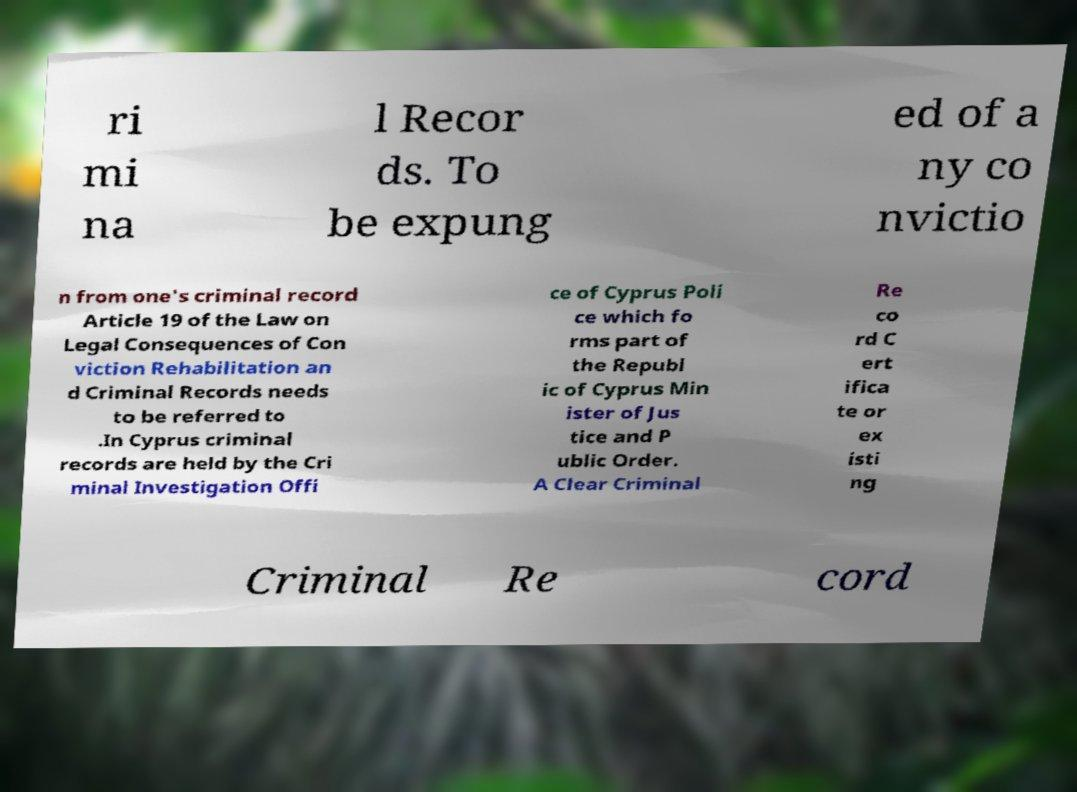There's text embedded in this image that I need extracted. Can you transcribe it verbatim? ri mi na l Recor ds. To be expung ed of a ny co nvictio n from one's criminal record Article 19 of the Law on Legal Consequences of Con viction Rehabilitation an d Criminal Records needs to be referred to .In Cyprus criminal records are held by the Cri minal Investigation Offi ce of Cyprus Poli ce which fo rms part of the Republ ic of Cyprus Min ister of Jus tice and P ublic Order. A Clear Criminal Re co rd C ert ifica te or ex isti ng Criminal Re cord 